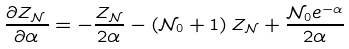Convert formula to latex. <formula><loc_0><loc_0><loc_500><loc_500>\frac { \partial Z _ { \mathcal { N } \, } } { \partial \alpha } = - \frac { Z _ { \mathcal { N } } } { 2 \alpha } - \left ( \mathcal { N } _ { 0 } + 1 \right ) Z _ { \mathcal { N } } + \frac { \mathcal { N } _ { 0 } e ^ { - \alpha } } { 2 \alpha }</formula> 